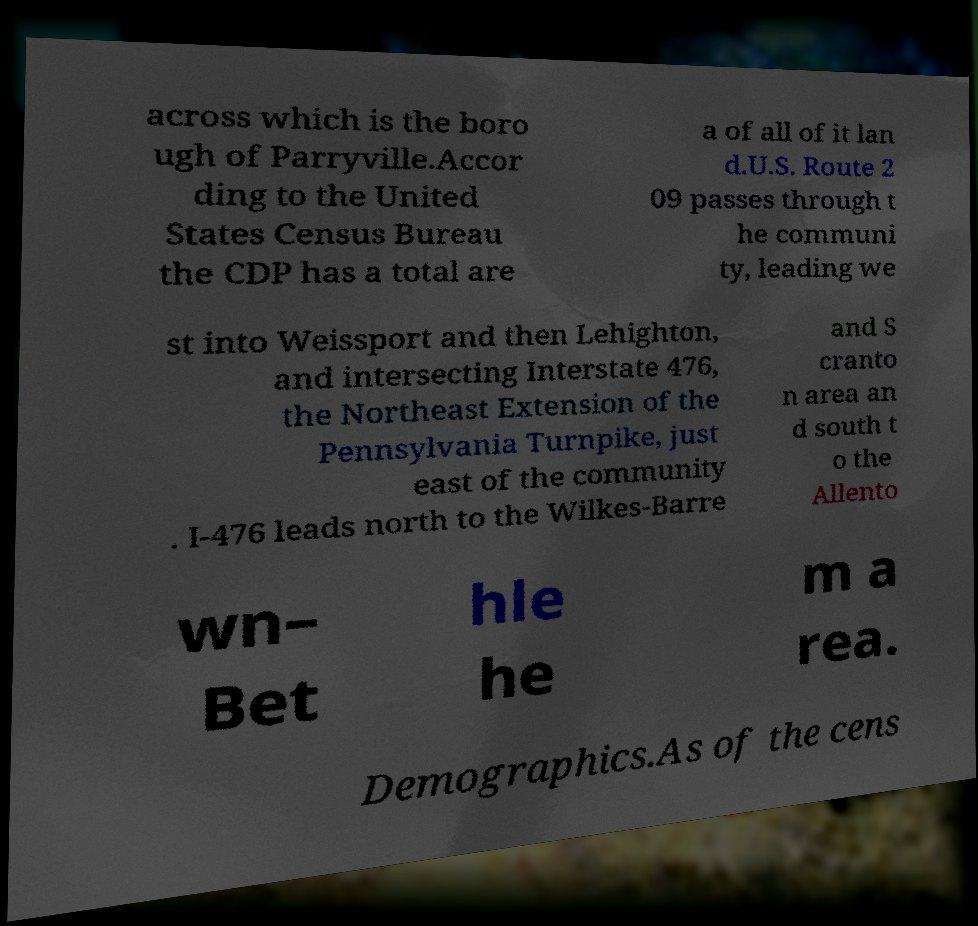There's text embedded in this image that I need extracted. Can you transcribe it verbatim? across which is the boro ugh of Parryville.Accor ding to the United States Census Bureau the CDP has a total are a of all of it lan d.U.S. Route 2 09 passes through t he communi ty, leading we st into Weissport and then Lehighton, and intersecting Interstate 476, the Northeast Extension of the Pennsylvania Turnpike, just east of the community . I-476 leads north to the Wilkes-Barre and S cranto n area an d south t o the Allento wn– Bet hle he m a rea. Demographics.As of the cens 